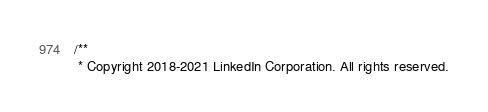Convert code to text. <code><loc_0><loc_0><loc_500><loc_500><_Java_>/**
 * Copyright 2018-2021 LinkedIn Corporation. All rights reserved.</code> 